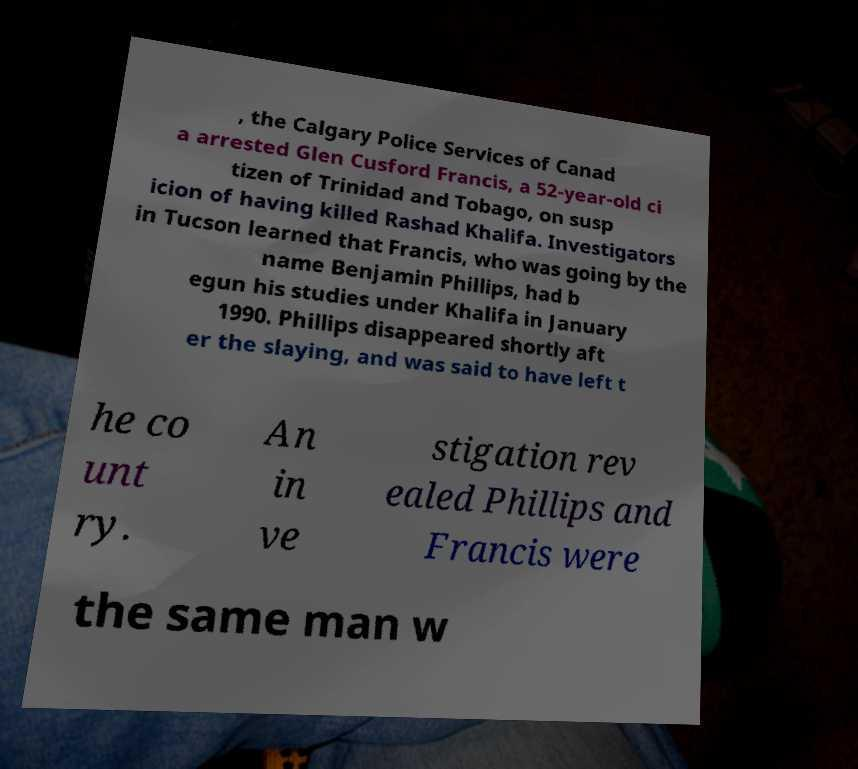I need the written content from this picture converted into text. Can you do that? , the Calgary Police Services of Canad a arrested Glen Cusford Francis, a 52-year-old ci tizen of Trinidad and Tobago, on susp icion of having killed Rashad Khalifa. Investigators in Tucson learned that Francis, who was going by the name Benjamin Phillips, had b egun his studies under Khalifa in January 1990. Phillips disappeared shortly aft er the slaying, and was said to have left t he co unt ry. An in ve stigation rev ealed Phillips and Francis were the same man w 